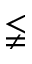<formula> <loc_0><loc_0><loc_500><loc_500>\lneqq</formula> 